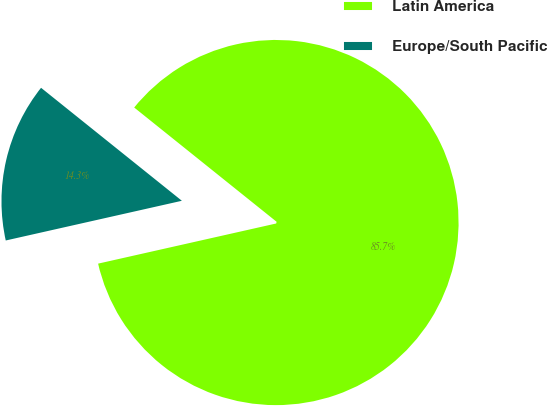<chart> <loc_0><loc_0><loc_500><loc_500><pie_chart><fcel>Latin America<fcel>Europe/South Pacific<nl><fcel>85.71%<fcel>14.29%<nl></chart> 